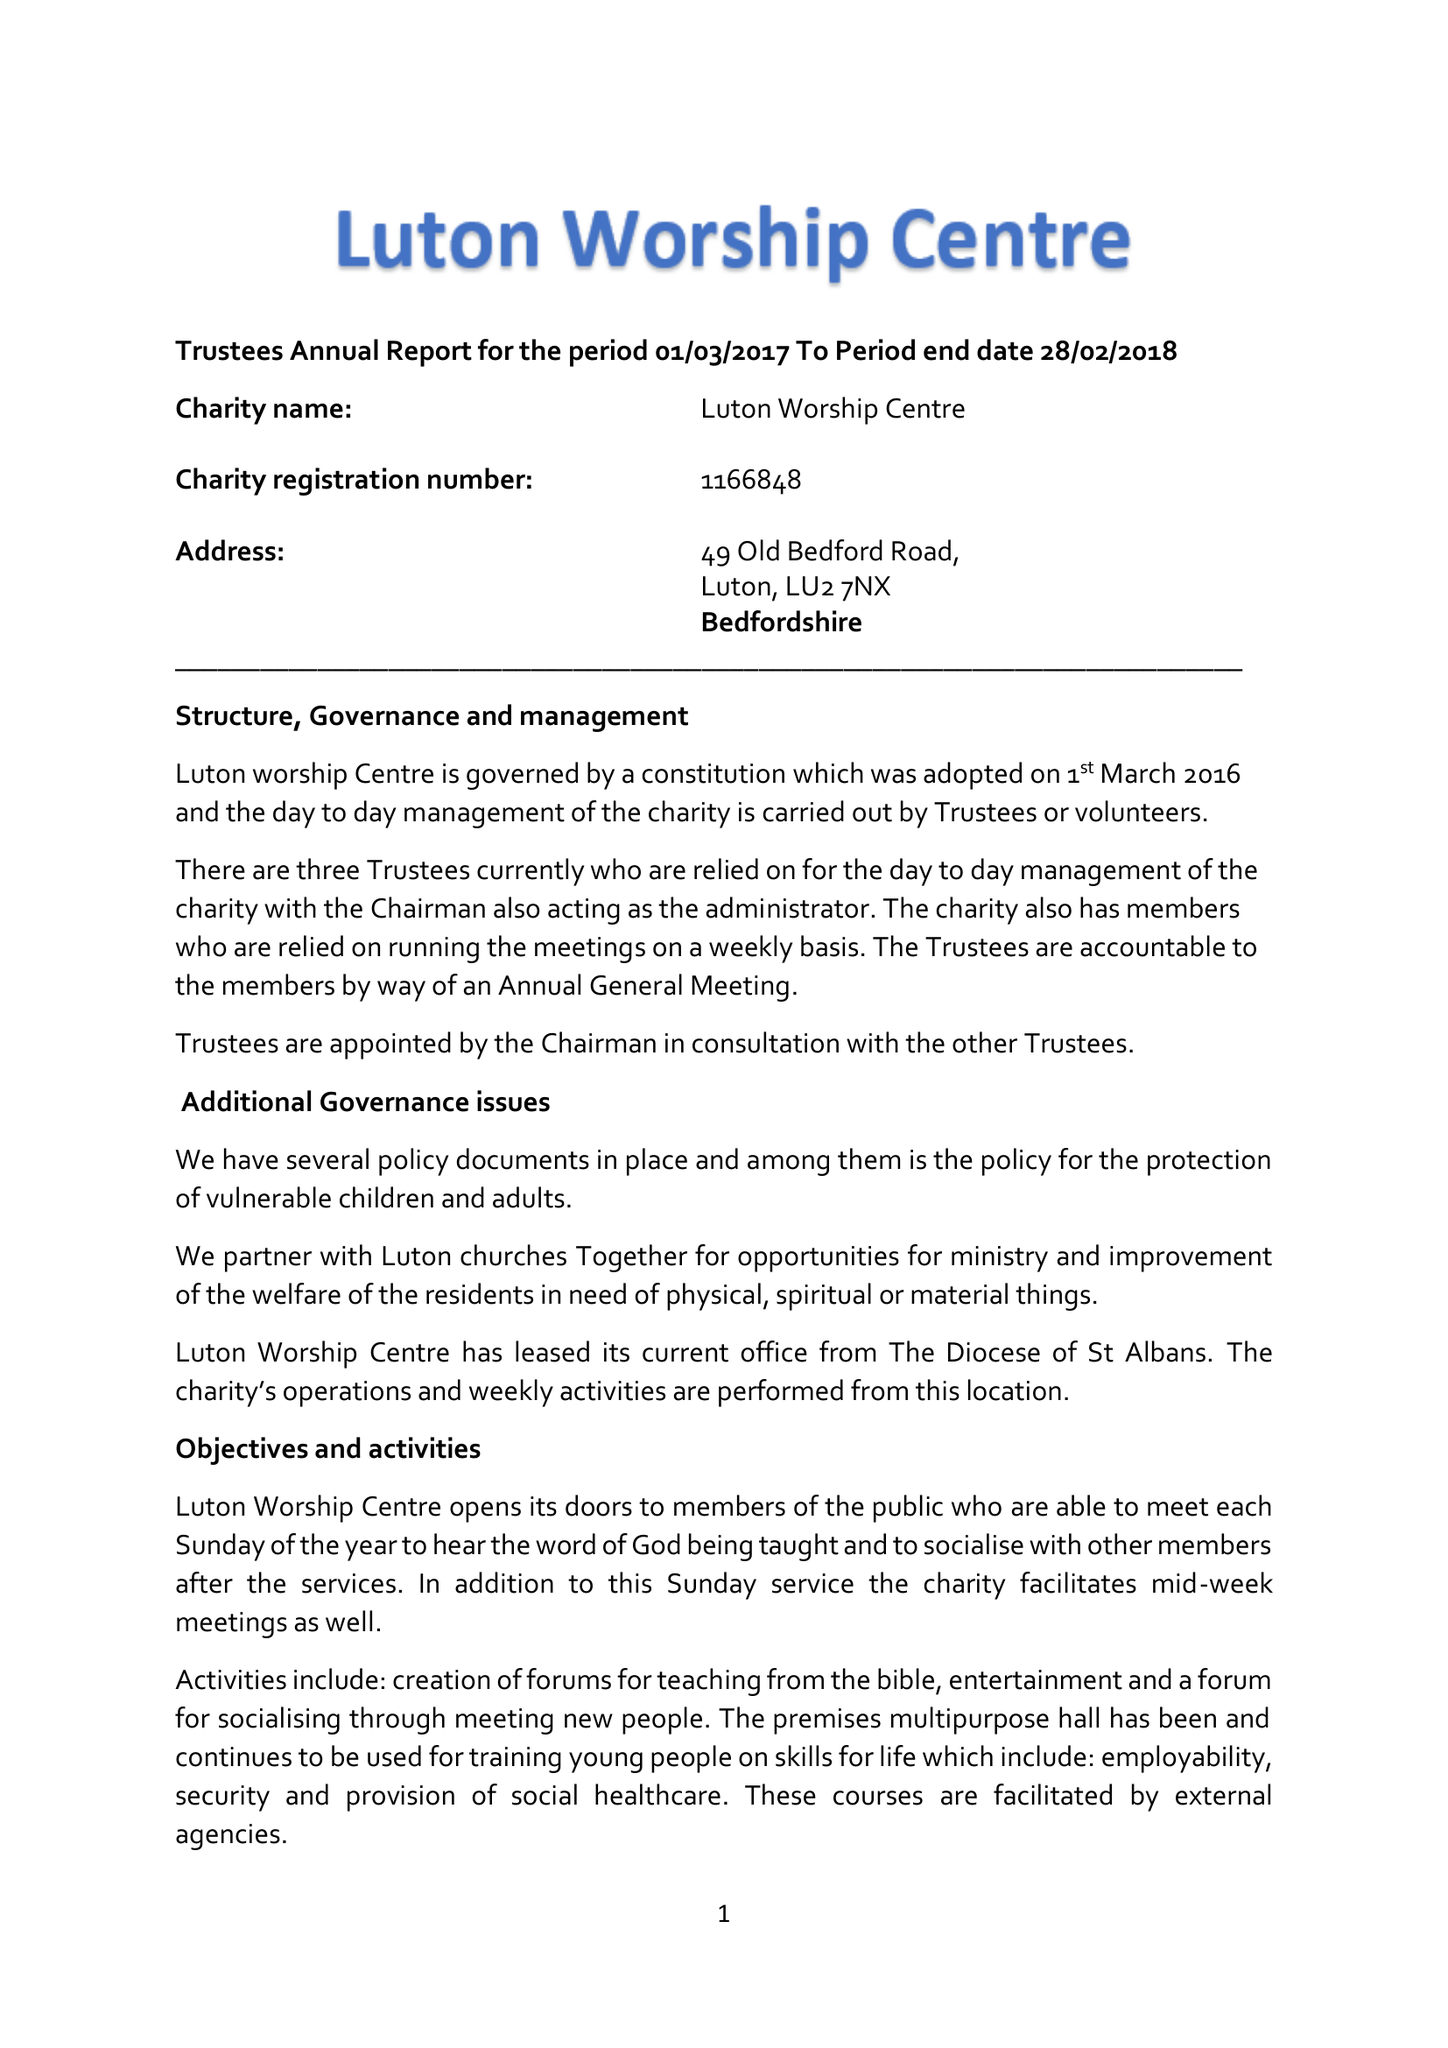What is the value for the address__postcode?
Answer the question using a single word or phrase. LU2 7NX 